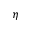Convert formula to latex. <formula><loc_0><loc_0><loc_500><loc_500>\eta</formula> 